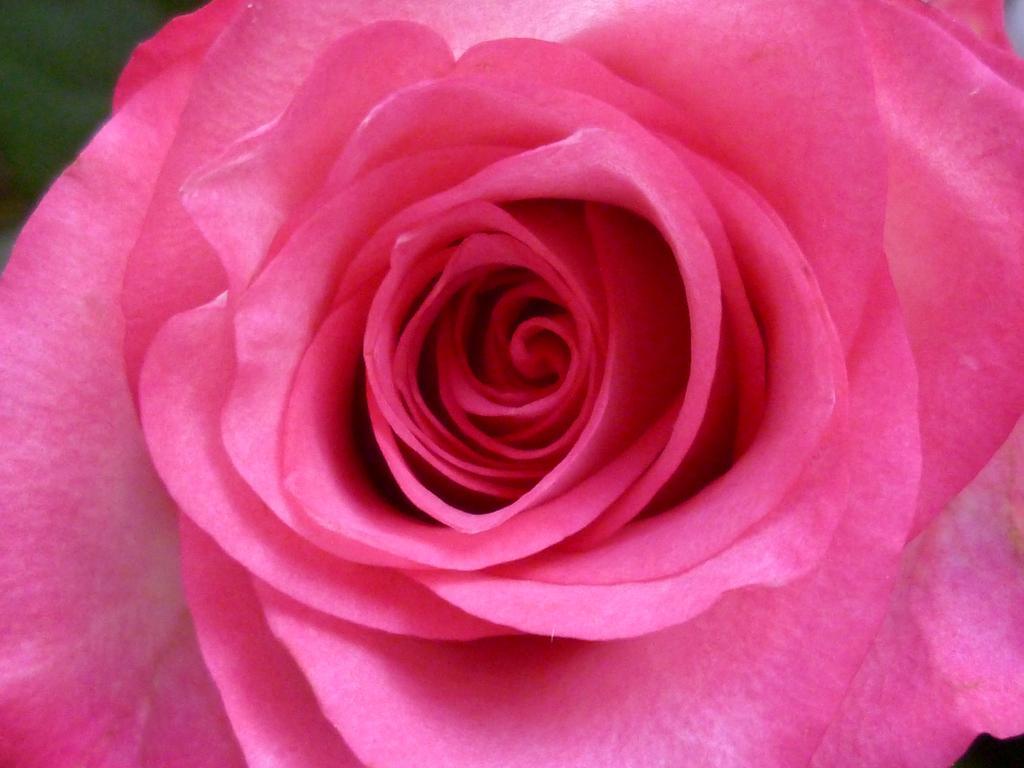In one or two sentences, can you explain what this image depicts? In this image in the foreground there is one rose flower. 